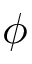Convert formula to latex. <formula><loc_0><loc_0><loc_500><loc_500>\phi</formula> 